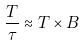Convert formula to latex. <formula><loc_0><loc_0><loc_500><loc_500>\frac { T } { \tau } \approx T \times B</formula> 